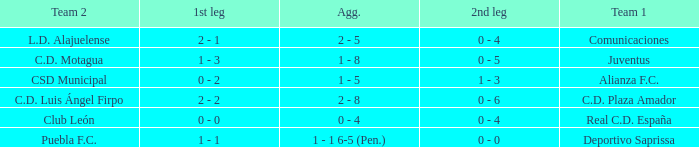What is the 1st leg where Team 1 is C.D. Plaza Amador? 2 - 2. I'm looking to parse the entire table for insights. Could you assist me with that? {'header': ['Team 2', '1st leg', 'Agg.', '2nd leg', 'Team 1'], 'rows': [['L.D. Alajuelense', '2 - 1', '2 - 5', '0 - 4', 'Comunicaciones'], ['C.D. Motagua', '1 - 3', '1 - 8', '0 - 5', 'Juventus'], ['CSD Municipal', '0 - 2', '1 - 5', '1 - 3', 'Alianza F.C.'], ['C.D. Luis Ángel Firpo', '2 - 2', '2 - 8', '0 - 6', 'C.D. Plaza Amador'], ['Club León', '0 - 0', '0 - 4', '0 - 4', 'Real C.D. España'], ['Puebla F.C.', '1 - 1', '1 - 1 6-5 (Pen.)', '0 - 0', 'Deportivo Saprissa']]} 